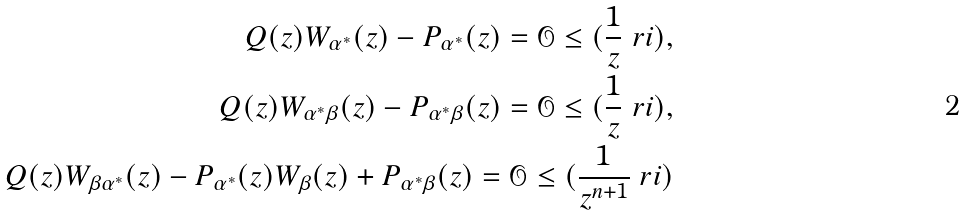<formula> <loc_0><loc_0><loc_500><loc_500>Q ( z ) W _ { \alpha ^ { * } } ( z ) - P _ { \alpha ^ { * } } ( z ) = \mathcal { O } \leq ( \frac { 1 } { z } \ r i ) , \\ Q ( z ) W _ { \alpha ^ { * } \beta } ( z ) - P _ { \alpha ^ { * } \beta } ( z ) = \mathcal { O } \leq ( \frac { 1 } { z } \ r i ) , \\ Q ( z ) W _ { \beta \alpha ^ { * } } ( z ) - P _ { \alpha ^ { * } } ( z ) W _ { \beta } ( z ) + P _ { \alpha ^ { * } \beta } ( z ) = \mathcal { O } \leq ( \frac { 1 } { z ^ { n + 1 } } \ r i )</formula> 